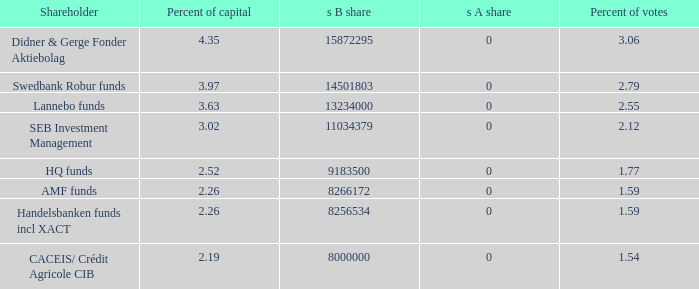Can you parse all the data within this table? {'header': ['Shareholder', 'Percent of capital', 's B share', 's A share', 'Percent of votes'], 'rows': [['Didner & Gerge Fonder Aktiebolag', '4.35', '15872295', '0', '3.06'], ['Swedbank Robur funds', '3.97', '14501803', '0', '2.79'], ['Lannebo funds', '3.63', '13234000', '0', '2.55'], ['SEB Investment Management', '3.02', '11034379', '0', '2.12'], ['HQ funds', '2.52', '9183500', '0', '1.77'], ['AMF funds', '2.26', '8266172', '0', '1.59'], ['Handelsbanken funds incl XACT', '2.26', '8256534', '0', '1.59'], ['CACEIS/ Crédit Agricole CIB', '2.19', '8000000', '0', '1.54']]} What is the percent of capital for the shareholder that has a s B share of 8256534?  2.26. 